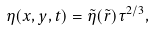<formula> <loc_0><loc_0><loc_500><loc_500>\eta ( x , y , t ) = \tilde { \eta } ( \tilde { r } ) \tau ^ { 2 / 3 } ,</formula> 